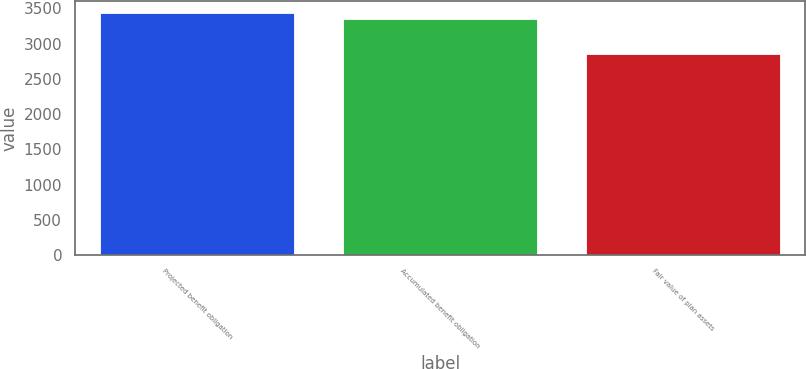Convert chart. <chart><loc_0><loc_0><loc_500><loc_500><bar_chart><fcel>Projected benefit obligation<fcel>Accumulated benefit obligation<fcel>Fair value of plan assets<nl><fcel>3433.6<fcel>3357.1<fcel>2851.4<nl></chart> 